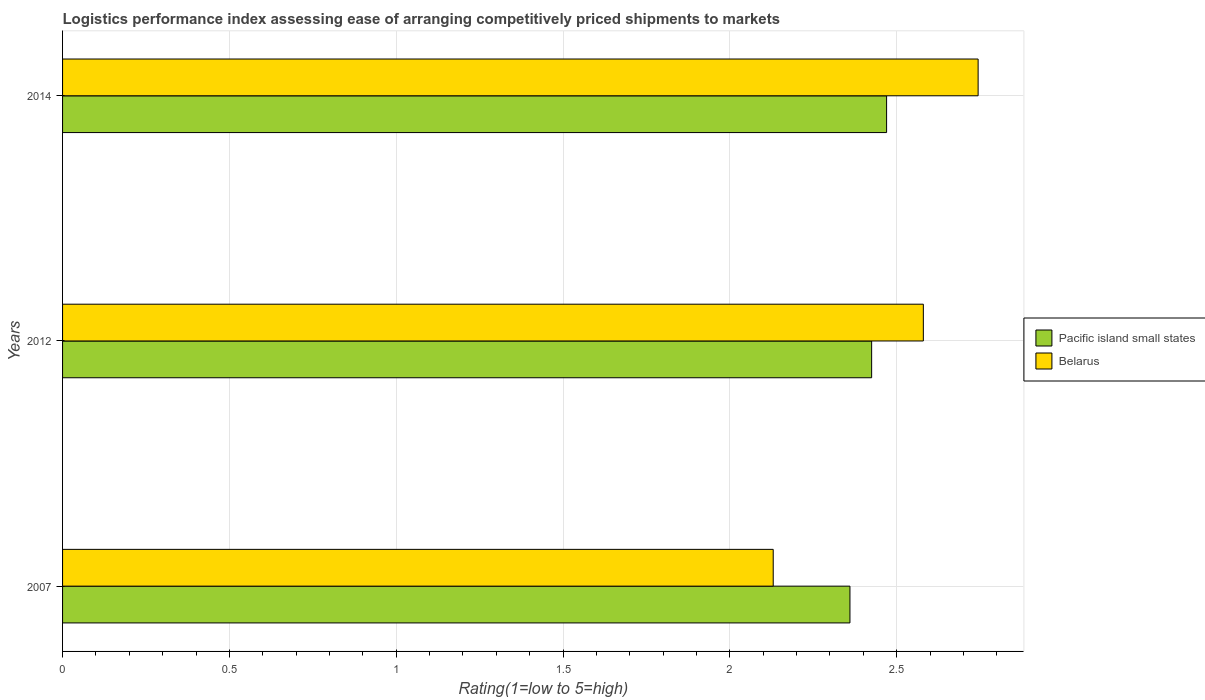How many groups of bars are there?
Provide a succinct answer. 3. Are the number of bars on each tick of the Y-axis equal?
Your answer should be very brief. Yes. In how many cases, is the number of bars for a given year not equal to the number of legend labels?
Keep it short and to the point. 0. What is the Logistic performance index in Pacific island small states in 2014?
Provide a succinct answer. 2.47. Across all years, what is the maximum Logistic performance index in Pacific island small states?
Provide a short and direct response. 2.47. Across all years, what is the minimum Logistic performance index in Belarus?
Your answer should be very brief. 2.13. In which year was the Logistic performance index in Pacific island small states maximum?
Make the answer very short. 2014. In which year was the Logistic performance index in Belarus minimum?
Make the answer very short. 2007. What is the total Logistic performance index in Pacific island small states in the graph?
Your response must be concise. 7.25. What is the difference between the Logistic performance index in Pacific island small states in 2007 and that in 2012?
Offer a terse response. -0.06. What is the difference between the Logistic performance index in Pacific island small states in 2014 and the Logistic performance index in Belarus in 2007?
Provide a short and direct response. 0.34. What is the average Logistic performance index in Pacific island small states per year?
Keep it short and to the point. 2.42. In the year 2012, what is the difference between the Logistic performance index in Belarus and Logistic performance index in Pacific island small states?
Keep it short and to the point. 0.16. What is the ratio of the Logistic performance index in Pacific island small states in 2007 to that in 2012?
Offer a very short reply. 0.97. Is the Logistic performance index in Belarus in 2007 less than that in 2014?
Your response must be concise. Yes. What is the difference between the highest and the second highest Logistic performance index in Pacific island small states?
Provide a short and direct response. 0.04. What is the difference between the highest and the lowest Logistic performance index in Belarus?
Ensure brevity in your answer.  0.61. In how many years, is the Logistic performance index in Pacific island small states greater than the average Logistic performance index in Pacific island small states taken over all years?
Ensure brevity in your answer.  2. Is the sum of the Logistic performance index in Pacific island small states in 2007 and 2014 greater than the maximum Logistic performance index in Belarus across all years?
Your response must be concise. Yes. What does the 1st bar from the top in 2007 represents?
Ensure brevity in your answer.  Belarus. What does the 1st bar from the bottom in 2012 represents?
Give a very brief answer. Pacific island small states. How many bars are there?
Your answer should be compact. 6. Are all the bars in the graph horizontal?
Keep it short and to the point. Yes. How many years are there in the graph?
Your response must be concise. 3. What is the difference between two consecutive major ticks on the X-axis?
Offer a very short reply. 0.5. Are the values on the major ticks of X-axis written in scientific E-notation?
Provide a short and direct response. No. Does the graph contain any zero values?
Provide a short and direct response. No. Where does the legend appear in the graph?
Offer a very short reply. Center right. What is the title of the graph?
Provide a short and direct response. Logistics performance index assessing ease of arranging competitively priced shipments to markets. Does "Caribbean small states" appear as one of the legend labels in the graph?
Your response must be concise. No. What is the label or title of the X-axis?
Give a very brief answer. Rating(1=low to 5=high). What is the Rating(1=low to 5=high) in Pacific island small states in 2007?
Keep it short and to the point. 2.36. What is the Rating(1=low to 5=high) of Belarus in 2007?
Ensure brevity in your answer.  2.13. What is the Rating(1=low to 5=high) in Pacific island small states in 2012?
Give a very brief answer. 2.42. What is the Rating(1=low to 5=high) in Belarus in 2012?
Ensure brevity in your answer.  2.58. What is the Rating(1=low to 5=high) of Pacific island small states in 2014?
Offer a terse response. 2.47. What is the Rating(1=low to 5=high) in Belarus in 2014?
Make the answer very short. 2.74. Across all years, what is the maximum Rating(1=low to 5=high) in Pacific island small states?
Offer a very short reply. 2.47. Across all years, what is the maximum Rating(1=low to 5=high) in Belarus?
Offer a terse response. 2.74. Across all years, what is the minimum Rating(1=low to 5=high) in Pacific island small states?
Make the answer very short. 2.36. Across all years, what is the minimum Rating(1=low to 5=high) of Belarus?
Provide a short and direct response. 2.13. What is the total Rating(1=low to 5=high) in Pacific island small states in the graph?
Make the answer very short. 7.25. What is the total Rating(1=low to 5=high) in Belarus in the graph?
Provide a short and direct response. 7.45. What is the difference between the Rating(1=low to 5=high) in Pacific island small states in 2007 and that in 2012?
Provide a succinct answer. -0.07. What is the difference between the Rating(1=low to 5=high) in Belarus in 2007 and that in 2012?
Your response must be concise. -0.45. What is the difference between the Rating(1=low to 5=high) of Pacific island small states in 2007 and that in 2014?
Offer a very short reply. -0.11. What is the difference between the Rating(1=low to 5=high) of Belarus in 2007 and that in 2014?
Keep it short and to the point. -0.61. What is the difference between the Rating(1=low to 5=high) of Pacific island small states in 2012 and that in 2014?
Offer a terse response. -0.04. What is the difference between the Rating(1=low to 5=high) in Belarus in 2012 and that in 2014?
Keep it short and to the point. -0.16. What is the difference between the Rating(1=low to 5=high) in Pacific island small states in 2007 and the Rating(1=low to 5=high) in Belarus in 2012?
Provide a short and direct response. -0.22. What is the difference between the Rating(1=low to 5=high) in Pacific island small states in 2007 and the Rating(1=low to 5=high) in Belarus in 2014?
Provide a succinct answer. -0.38. What is the difference between the Rating(1=low to 5=high) in Pacific island small states in 2012 and the Rating(1=low to 5=high) in Belarus in 2014?
Provide a succinct answer. -0.32. What is the average Rating(1=low to 5=high) in Pacific island small states per year?
Your response must be concise. 2.42. What is the average Rating(1=low to 5=high) of Belarus per year?
Your response must be concise. 2.48. In the year 2007, what is the difference between the Rating(1=low to 5=high) in Pacific island small states and Rating(1=low to 5=high) in Belarus?
Your answer should be very brief. 0.23. In the year 2012, what is the difference between the Rating(1=low to 5=high) of Pacific island small states and Rating(1=low to 5=high) of Belarus?
Your answer should be very brief. -0.15. In the year 2014, what is the difference between the Rating(1=low to 5=high) in Pacific island small states and Rating(1=low to 5=high) in Belarus?
Provide a succinct answer. -0.27. What is the ratio of the Rating(1=low to 5=high) of Pacific island small states in 2007 to that in 2012?
Keep it short and to the point. 0.97. What is the ratio of the Rating(1=low to 5=high) in Belarus in 2007 to that in 2012?
Offer a terse response. 0.83. What is the ratio of the Rating(1=low to 5=high) of Pacific island small states in 2007 to that in 2014?
Your answer should be very brief. 0.96. What is the ratio of the Rating(1=low to 5=high) in Belarus in 2007 to that in 2014?
Give a very brief answer. 0.78. What is the ratio of the Rating(1=low to 5=high) of Pacific island small states in 2012 to that in 2014?
Keep it short and to the point. 0.98. What is the ratio of the Rating(1=low to 5=high) in Belarus in 2012 to that in 2014?
Your response must be concise. 0.94. What is the difference between the highest and the second highest Rating(1=low to 5=high) in Pacific island small states?
Provide a succinct answer. 0.04. What is the difference between the highest and the second highest Rating(1=low to 5=high) of Belarus?
Offer a terse response. 0.16. What is the difference between the highest and the lowest Rating(1=low to 5=high) of Pacific island small states?
Ensure brevity in your answer.  0.11. What is the difference between the highest and the lowest Rating(1=low to 5=high) of Belarus?
Offer a terse response. 0.61. 